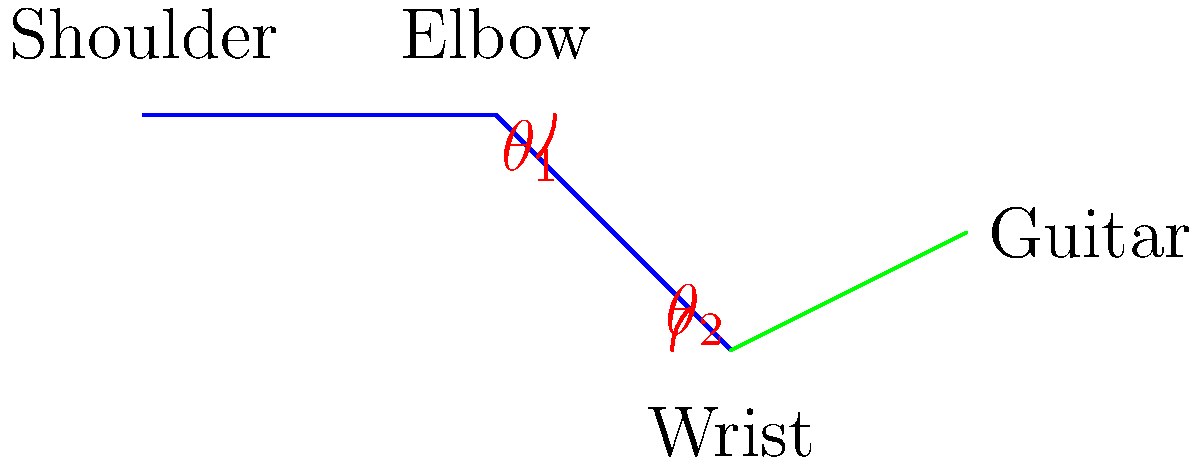In Nick Jonas's iconic guitar-playing stance, his arm forms two key angles: $\theta_1$ at the shoulder and $\theta_2$ at the elbow. If $\theta_1 = 45°$ and $\theta_2 = 90°$, what is the total angular displacement of Nick's arm from shoulder to wrist? To find the total angular displacement of Nick Jonas's arm while playing guitar, we need to follow these steps:

1. Identify the angles: We have $\theta_1 = 45°$ at the shoulder and $\theta_2 = 90°$ at the elbow.

2. Understand angular displacement: The total angular displacement is the sum of all angle changes along the arm.

3. Add the angles: 
   Total angular displacement = $\theta_1 + \theta_2$
   Total angular displacement = $45° + 90°$
   Total angular displacement = $135°$

4. Consider the direction: In this case, both angles are in the same direction (downward), so we simply add them without considering negative angles.

5. Express the final answer: The total angular displacement of Nick's arm from shoulder to wrist is 135°.
Answer: 135° 